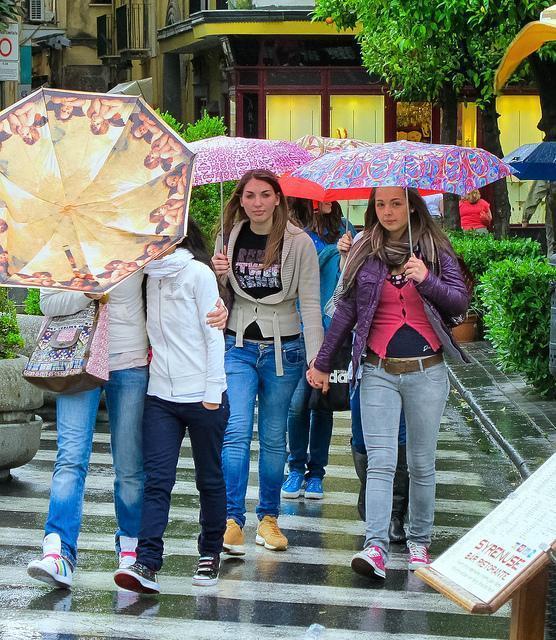How many people are visible?
Give a very brief answer. 5. How many umbrellas can be seen?
Give a very brief answer. 4. How many handbags can be seen?
Give a very brief answer. 1. How many giraffes are there?
Give a very brief answer. 0. 